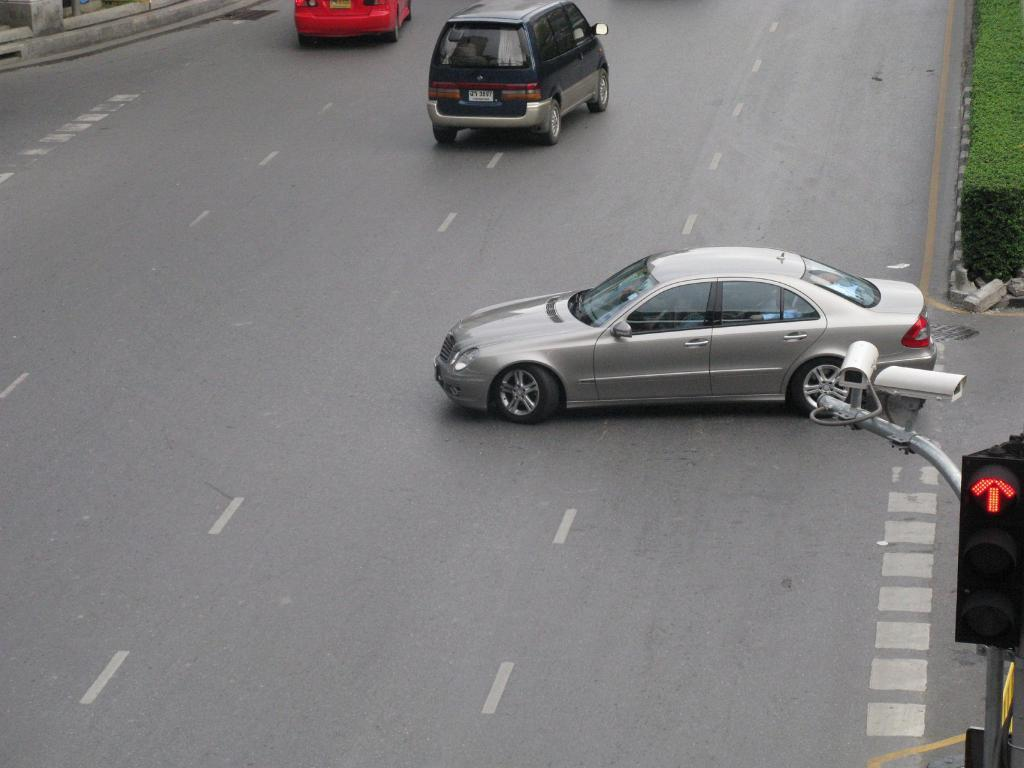What can be seen on the road in the image? There are motor vehicles on the road in the image. What helps regulate the traffic in the image? There are traffic lights in the image. What is the tall, slender object near the traffic lights? There is a traffic pole in the image. What device is used for surveillance in the image? A CCTV camera is present in the image. What type of vegetation is visible in the image? There is grass visible in the image. How many apples are hanging from the traffic pole in the image? There are no apples present in the image; the traffic pole is a part of the infrastructure, not a tree. What type of card is being used by the motor vehicles to navigate the road in the image? There is no mention of cards being used by the motor vehicles in the image; they are simply driving on the road. 